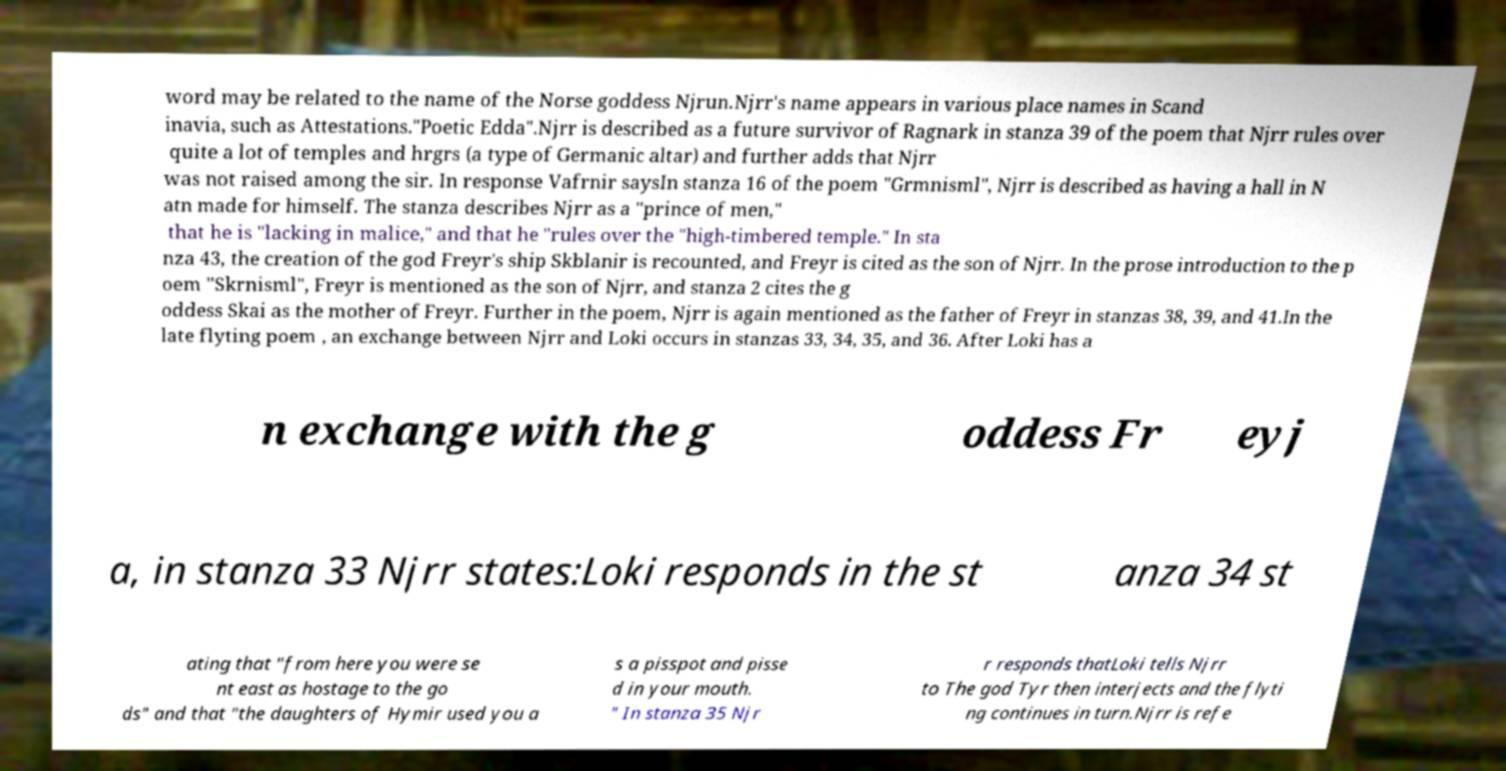Could you assist in decoding the text presented in this image and type it out clearly? word may be related to the name of the Norse goddess Njrun.Njrr's name appears in various place names in Scand inavia, such as Attestations."Poetic Edda".Njrr is described as a future survivor of Ragnark in stanza 39 of the poem that Njrr rules over quite a lot of temples and hrgrs (a type of Germanic altar) and further adds that Njrr was not raised among the sir. In response Vafrnir saysIn stanza 16 of the poem "Grmnisml", Njrr is described as having a hall in N atn made for himself. The stanza describes Njrr as a "prince of men," that he is "lacking in malice," and that he "rules over the "high-timbered temple." In sta nza 43, the creation of the god Freyr's ship Skblanir is recounted, and Freyr is cited as the son of Njrr. In the prose introduction to the p oem "Skrnisml", Freyr is mentioned as the son of Njrr, and stanza 2 cites the g oddess Skai as the mother of Freyr. Further in the poem, Njrr is again mentioned as the father of Freyr in stanzas 38, 39, and 41.In the late flyting poem , an exchange between Njrr and Loki occurs in stanzas 33, 34, 35, and 36. After Loki has a n exchange with the g oddess Fr eyj a, in stanza 33 Njrr states:Loki responds in the st anza 34 st ating that "from here you were se nt east as hostage to the go ds" and that "the daughters of Hymir used you a s a pisspot and pisse d in your mouth. " In stanza 35 Njr r responds thatLoki tells Njrr to The god Tyr then interjects and the flyti ng continues in turn.Njrr is refe 